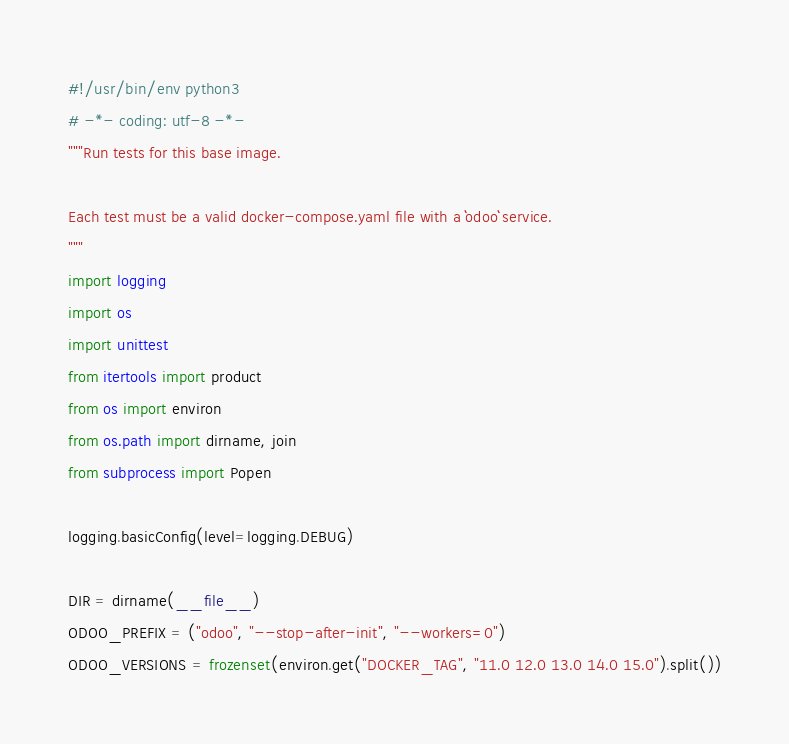<code> <loc_0><loc_0><loc_500><loc_500><_Python_>#!/usr/bin/env python3
# -*- coding: utf-8 -*-
"""Run tests for this base image.

Each test must be a valid docker-compose.yaml file with a ``odoo`` service.
"""
import logging
import os
import unittest
from itertools import product
from os import environ
from os.path import dirname, join
from subprocess import Popen

logging.basicConfig(level=logging.DEBUG)

DIR = dirname(__file__)
ODOO_PREFIX = ("odoo", "--stop-after-init", "--workers=0")
ODOO_VERSIONS = frozenset(environ.get("DOCKER_TAG", "11.0 12.0 13.0 14.0 15.0").split())</code> 